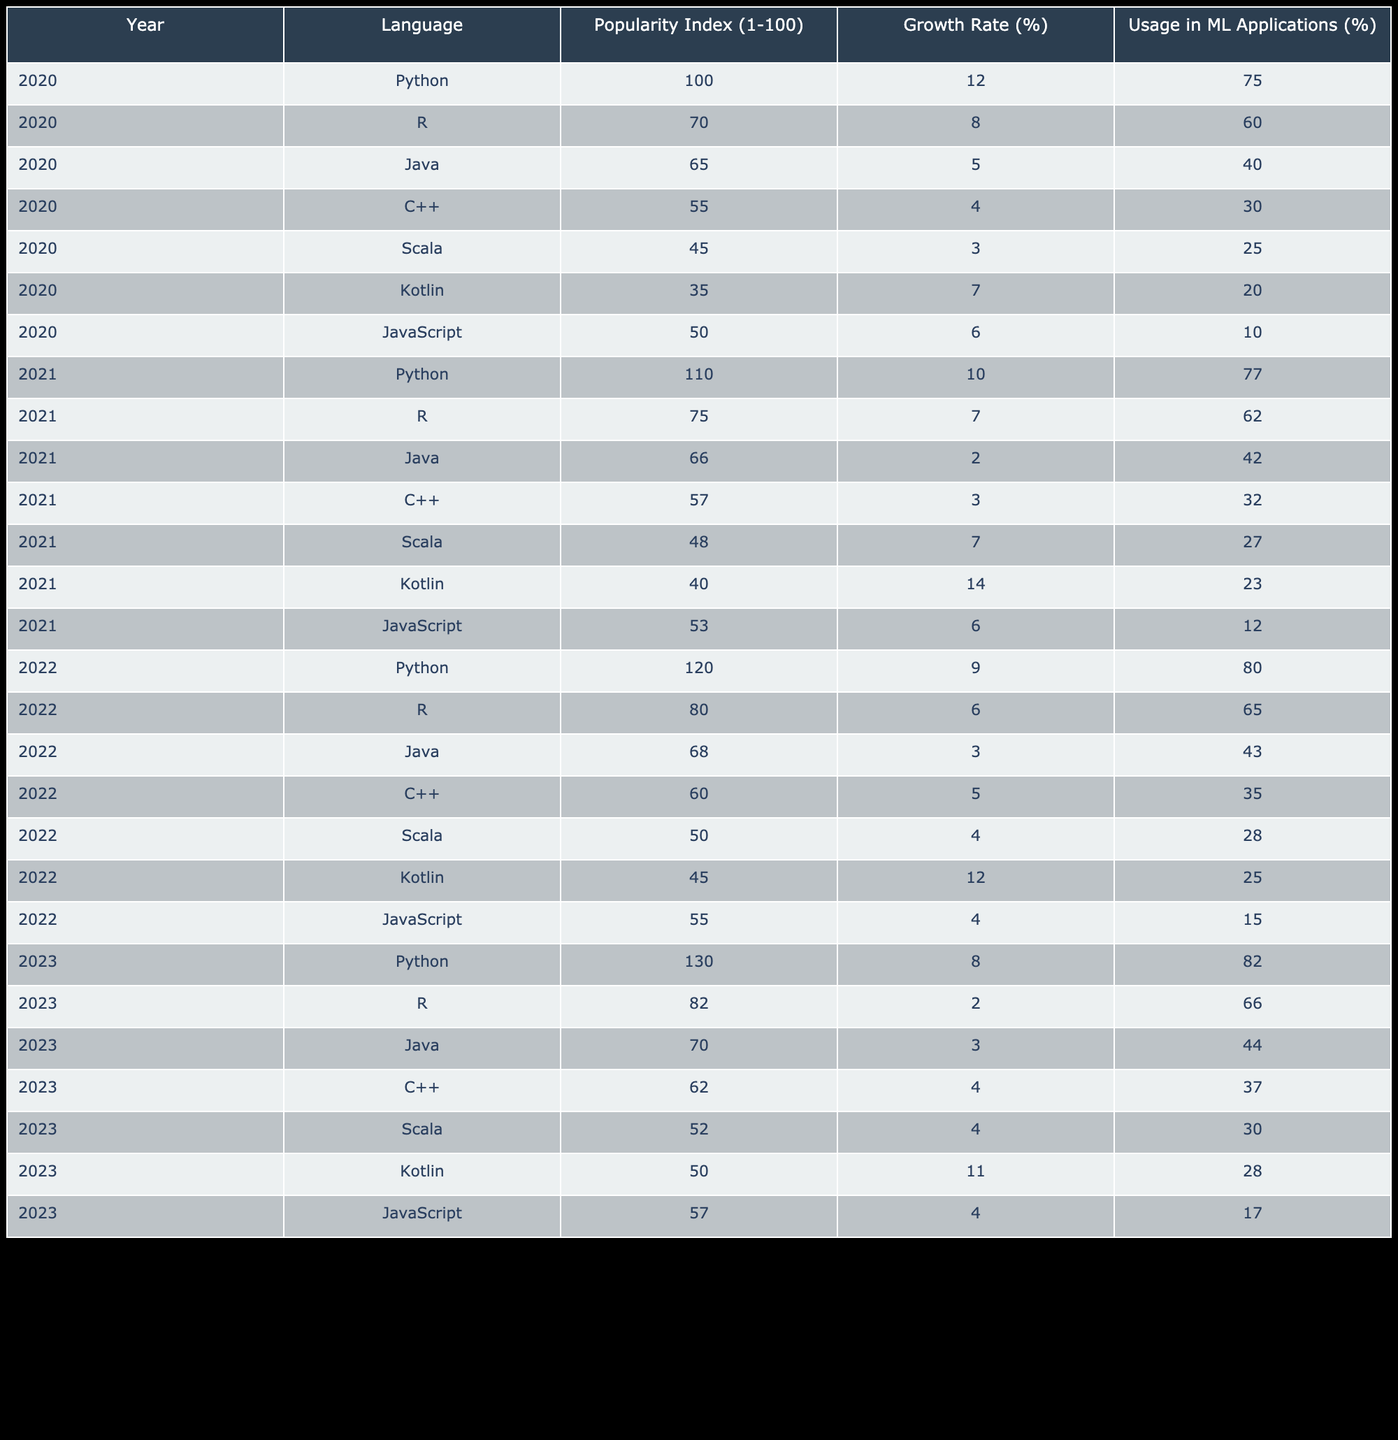What was the popularity index of Python in 2021? In the given table, we look for the row corresponding to Python in the year 2021, which shows a popularity index of 110.
Answer: 110 Which programming language had the highest growth rate in 2022? In 2022, we examine the growth rates provided for each programming language and find that Kotlin had the highest growth rate at 12%.
Answer: 12% Is it true that the popularity index of Kotlin increased every year from 2020 to 2023? Analyzing the popularity index values for Kotlin: 35 in 2020, 40 in 2021, 45 in 2022, and 50 in 2023, it shows a consistent increase each year. Thus, the statement is true.
Answer: Yes What is the average usage in machine learning applications for Java from 2020 to 2023? We sum the usage in ML applications for Java from each year: 40% (2020) + 42% (2021) + 43% (2022) + 44% (2023) = 169%. Then we divide by the total number of years (4), yielding an average of 169/4 = 42.25%.
Answer: 42.25% Which language showed the least growth from 2020 to 2023? By comparing the growth rates from 2020 to 2023 for each language, Java has a growth rate of 3% during this period, which is less than others.
Answer: Java What is the change in Python's popularity index from 2020 to 2023? We take the popularity index for Python in 2020 (100) and the index in 2023 (130). The change is calculated as 130 - 100 = 30, indicating an increase in popularity.
Answer: 30 How many programming languages had a popularity index of 55 or higher in 2023? Looking at the 2023 data, the languages with a popularity index of 55 or higher are Python (130), R (82), Java (70), and C++ (62), totaling four languages.
Answer: 4 What percentage of R's usage in machine learning applications decreased from 2020 to 2023? R's usage in ML applications was 60% in 2020 and decreased to 66% in 2023. Thus, it actually represents a decrease of 60 - 66 = -6% (indicating improvement, not decrease).
Answer: No decrease 